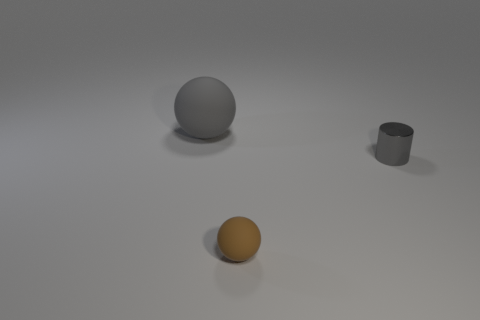Add 3 large rubber things. How many objects exist? 6 Subtract all cylinders. How many objects are left? 2 Add 3 cylinders. How many cylinders are left? 4 Add 2 spheres. How many spheres exist? 4 Subtract 0 yellow blocks. How many objects are left? 3 Subtract all brown matte objects. Subtract all small yellow matte cylinders. How many objects are left? 2 